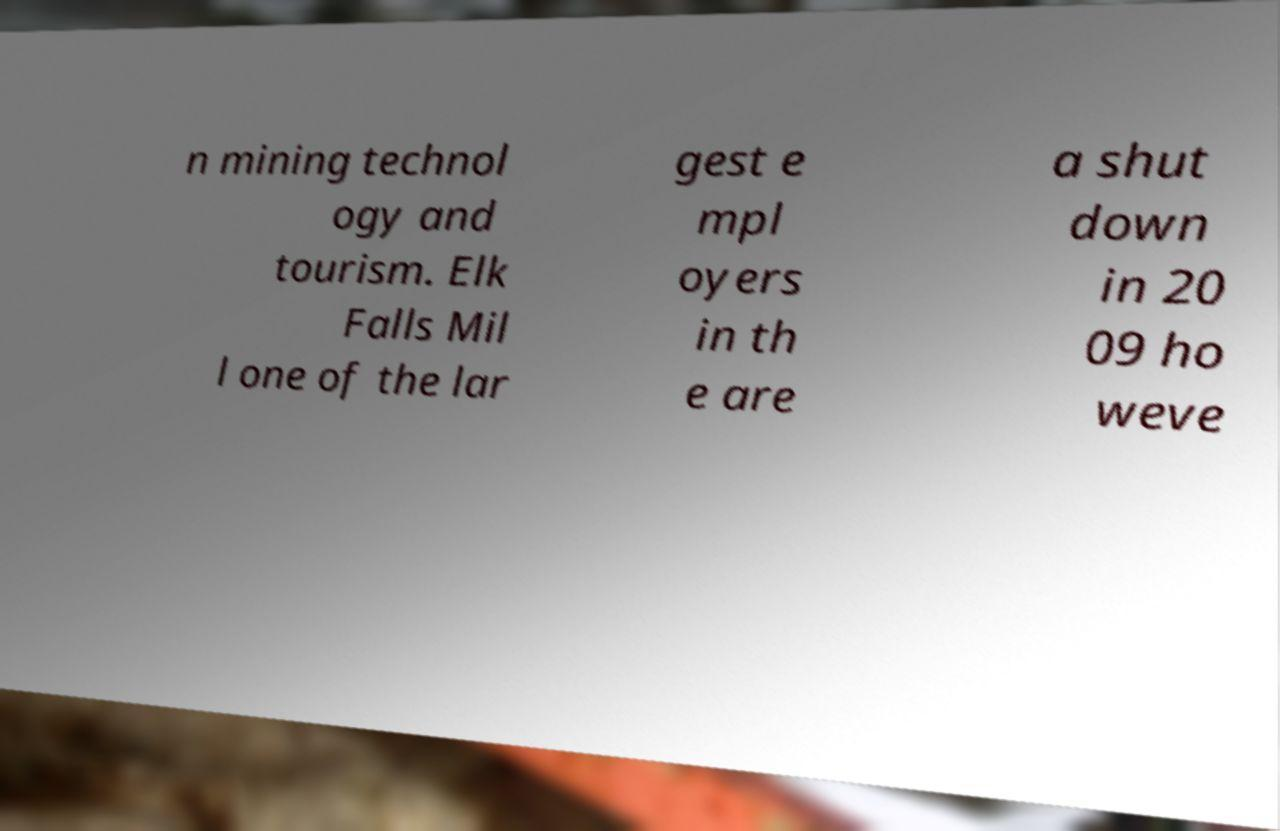For documentation purposes, I need the text within this image transcribed. Could you provide that? n mining technol ogy and tourism. Elk Falls Mil l one of the lar gest e mpl oyers in th e are a shut down in 20 09 ho weve 